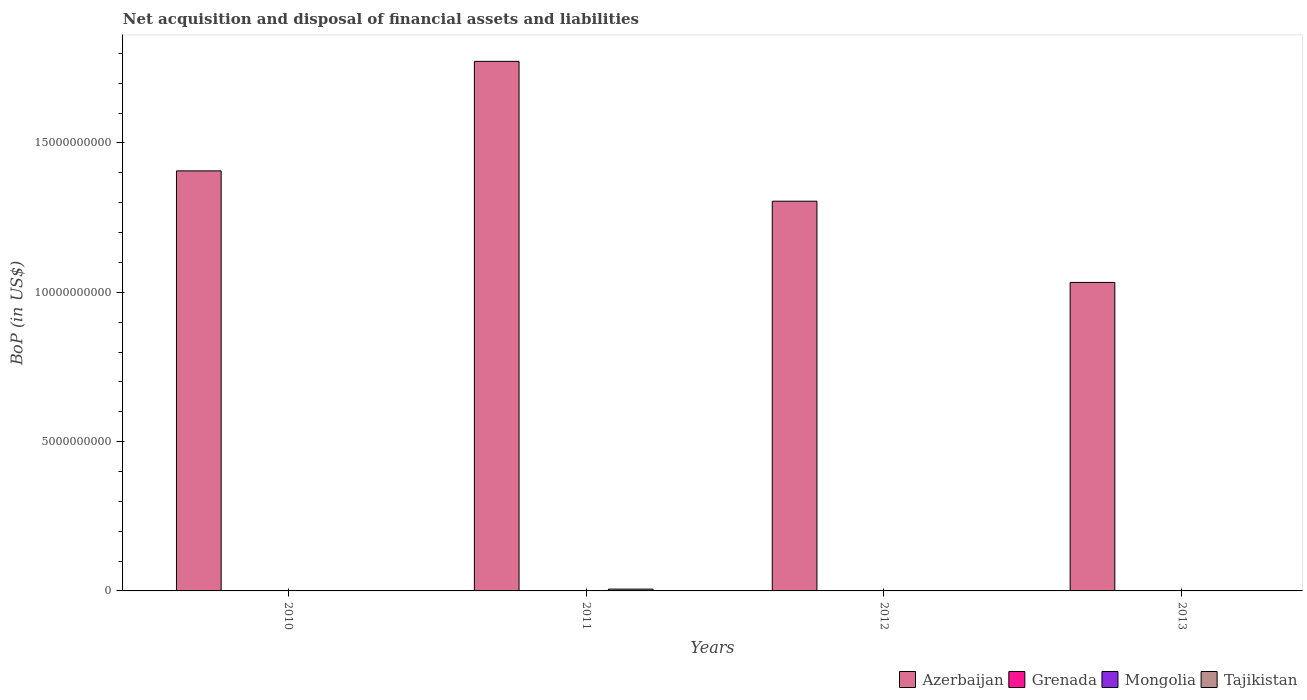Are the number of bars per tick equal to the number of legend labels?
Make the answer very short. No. Are the number of bars on each tick of the X-axis equal?
Ensure brevity in your answer.  No. How many bars are there on the 2nd tick from the left?
Your answer should be very brief. 2. What is the label of the 1st group of bars from the left?
Your answer should be very brief. 2010. What is the Balance of Payments in Azerbaijan in 2011?
Provide a short and direct response. 1.77e+1. Across all years, what is the maximum Balance of Payments in Azerbaijan?
Offer a terse response. 1.77e+1. Across all years, what is the minimum Balance of Payments in Azerbaijan?
Your response must be concise. 1.03e+1. What is the difference between the Balance of Payments in Azerbaijan in 2010 and that in 2011?
Keep it short and to the point. -3.67e+09. What is the difference between the Balance of Payments in Mongolia in 2010 and the Balance of Payments in Tajikistan in 2013?
Offer a very short reply. 0. What is the average Balance of Payments in Azerbaijan per year?
Your answer should be very brief. 1.38e+1. In the year 2011, what is the difference between the Balance of Payments in Tajikistan and Balance of Payments in Azerbaijan?
Offer a terse response. -1.77e+1. What is the difference between the highest and the second highest Balance of Payments in Azerbaijan?
Give a very brief answer. 3.67e+09. What is the difference between the highest and the lowest Balance of Payments in Azerbaijan?
Give a very brief answer. 7.40e+09. In how many years, is the Balance of Payments in Tajikistan greater than the average Balance of Payments in Tajikistan taken over all years?
Keep it short and to the point. 1. Is it the case that in every year, the sum of the Balance of Payments in Grenada and Balance of Payments in Mongolia is greater than the sum of Balance of Payments in Tajikistan and Balance of Payments in Azerbaijan?
Your answer should be compact. No. Where does the legend appear in the graph?
Give a very brief answer. Bottom right. How many legend labels are there?
Offer a very short reply. 4. How are the legend labels stacked?
Provide a short and direct response. Horizontal. What is the title of the graph?
Make the answer very short. Net acquisition and disposal of financial assets and liabilities. Does "Eritrea" appear as one of the legend labels in the graph?
Your response must be concise. No. What is the label or title of the Y-axis?
Ensure brevity in your answer.  BoP (in US$). What is the BoP (in US$) of Azerbaijan in 2010?
Offer a very short reply. 1.41e+1. What is the BoP (in US$) of Grenada in 2010?
Give a very brief answer. 0. What is the BoP (in US$) of Mongolia in 2010?
Offer a terse response. 0. What is the BoP (in US$) in Azerbaijan in 2011?
Offer a very short reply. 1.77e+1. What is the BoP (in US$) of Tajikistan in 2011?
Your answer should be very brief. 6.09e+07. What is the BoP (in US$) in Azerbaijan in 2012?
Provide a short and direct response. 1.30e+1. What is the BoP (in US$) in Grenada in 2012?
Give a very brief answer. 0. What is the BoP (in US$) in Mongolia in 2012?
Your response must be concise. 0. What is the BoP (in US$) in Azerbaijan in 2013?
Provide a succinct answer. 1.03e+1. What is the BoP (in US$) in Grenada in 2013?
Provide a succinct answer. 0. What is the BoP (in US$) in Mongolia in 2013?
Your response must be concise. 0. What is the BoP (in US$) of Tajikistan in 2013?
Your answer should be compact. 0. Across all years, what is the maximum BoP (in US$) in Azerbaijan?
Keep it short and to the point. 1.77e+1. Across all years, what is the maximum BoP (in US$) of Tajikistan?
Give a very brief answer. 6.09e+07. Across all years, what is the minimum BoP (in US$) in Azerbaijan?
Your answer should be very brief. 1.03e+1. What is the total BoP (in US$) in Azerbaijan in the graph?
Your answer should be compact. 5.52e+1. What is the total BoP (in US$) in Tajikistan in the graph?
Your answer should be compact. 6.09e+07. What is the difference between the BoP (in US$) in Azerbaijan in 2010 and that in 2011?
Provide a succinct answer. -3.67e+09. What is the difference between the BoP (in US$) of Azerbaijan in 2010 and that in 2012?
Your answer should be very brief. 1.02e+09. What is the difference between the BoP (in US$) of Azerbaijan in 2010 and that in 2013?
Offer a terse response. 3.74e+09. What is the difference between the BoP (in US$) of Azerbaijan in 2011 and that in 2012?
Your response must be concise. 4.68e+09. What is the difference between the BoP (in US$) in Azerbaijan in 2011 and that in 2013?
Offer a terse response. 7.40e+09. What is the difference between the BoP (in US$) of Azerbaijan in 2012 and that in 2013?
Provide a short and direct response. 2.72e+09. What is the difference between the BoP (in US$) of Azerbaijan in 2010 and the BoP (in US$) of Tajikistan in 2011?
Keep it short and to the point. 1.40e+1. What is the average BoP (in US$) of Azerbaijan per year?
Offer a terse response. 1.38e+1. What is the average BoP (in US$) in Grenada per year?
Ensure brevity in your answer.  0. What is the average BoP (in US$) of Tajikistan per year?
Make the answer very short. 1.52e+07. In the year 2011, what is the difference between the BoP (in US$) in Azerbaijan and BoP (in US$) in Tajikistan?
Make the answer very short. 1.77e+1. What is the ratio of the BoP (in US$) in Azerbaijan in 2010 to that in 2011?
Keep it short and to the point. 0.79. What is the ratio of the BoP (in US$) of Azerbaijan in 2010 to that in 2012?
Provide a short and direct response. 1.08. What is the ratio of the BoP (in US$) in Azerbaijan in 2010 to that in 2013?
Your answer should be compact. 1.36. What is the ratio of the BoP (in US$) of Azerbaijan in 2011 to that in 2012?
Provide a short and direct response. 1.36. What is the ratio of the BoP (in US$) in Azerbaijan in 2011 to that in 2013?
Your response must be concise. 1.72. What is the ratio of the BoP (in US$) of Azerbaijan in 2012 to that in 2013?
Offer a terse response. 1.26. What is the difference between the highest and the second highest BoP (in US$) in Azerbaijan?
Your answer should be compact. 3.67e+09. What is the difference between the highest and the lowest BoP (in US$) in Azerbaijan?
Offer a very short reply. 7.40e+09. What is the difference between the highest and the lowest BoP (in US$) in Tajikistan?
Your answer should be very brief. 6.09e+07. 